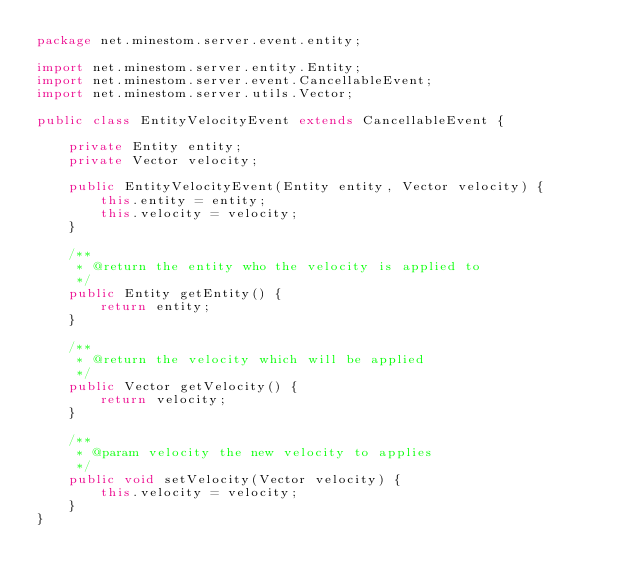Convert code to text. <code><loc_0><loc_0><loc_500><loc_500><_Java_>package net.minestom.server.event.entity;

import net.minestom.server.entity.Entity;
import net.minestom.server.event.CancellableEvent;
import net.minestom.server.utils.Vector;

public class EntityVelocityEvent extends CancellableEvent {

    private Entity entity;
    private Vector velocity;

    public EntityVelocityEvent(Entity entity, Vector velocity) {
        this.entity = entity;
        this.velocity = velocity;
    }

    /**
     * @return the entity who the velocity is applied to
     */
    public Entity getEntity() {
        return entity;
    }

    /**
     * @return the velocity which will be applied
     */
    public Vector getVelocity() {
        return velocity;
    }

    /**
     * @param velocity the new velocity to applies
     */
    public void setVelocity(Vector velocity) {
        this.velocity = velocity;
    }
}
</code> 